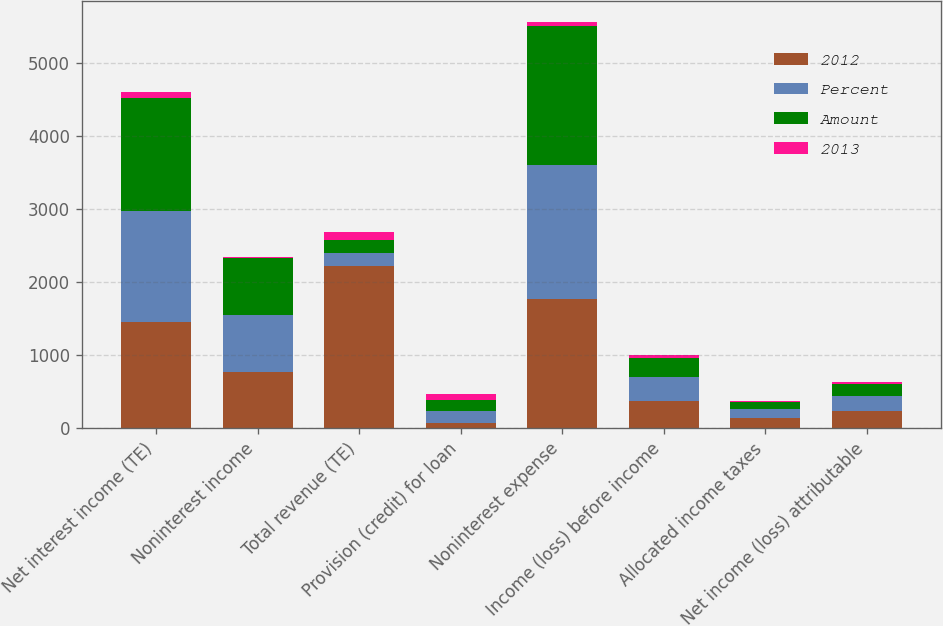Convert chart. <chart><loc_0><loc_0><loc_500><loc_500><stacked_bar_chart><ecel><fcel>Net interest income (TE)<fcel>Noninterest income<fcel>Total revenue (TE)<fcel>Provision (credit) for loan<fcel>Noninterest expense<fcel>Income (loss) before income<fcel>Allocated income taxes<fcel>Net income (loss) attributable<nl><fcel>2012<fcel>1448<fcel>769<fcel>2217<fcel>74<fcel>1770<fcel>373<fcel>139<fcel>234<nl><fcel>Percent<fcel>1532<fcel>784<fcel>183.5<fcel>155<fcel>1835<fcel>326<fcel>121<fcel>205<nl><fcel>Amount<fcel>1537<fcel>771<fcel>183.5<fcel>150<fcel>1900<fcel>258<fcel>96<fcel>162<nl><fcel>2013<fcel>84<fcel>15<fcel>99<fcel>81<fcel>65<fcel>47<fcel>18<fcel>29<nl></chart> 